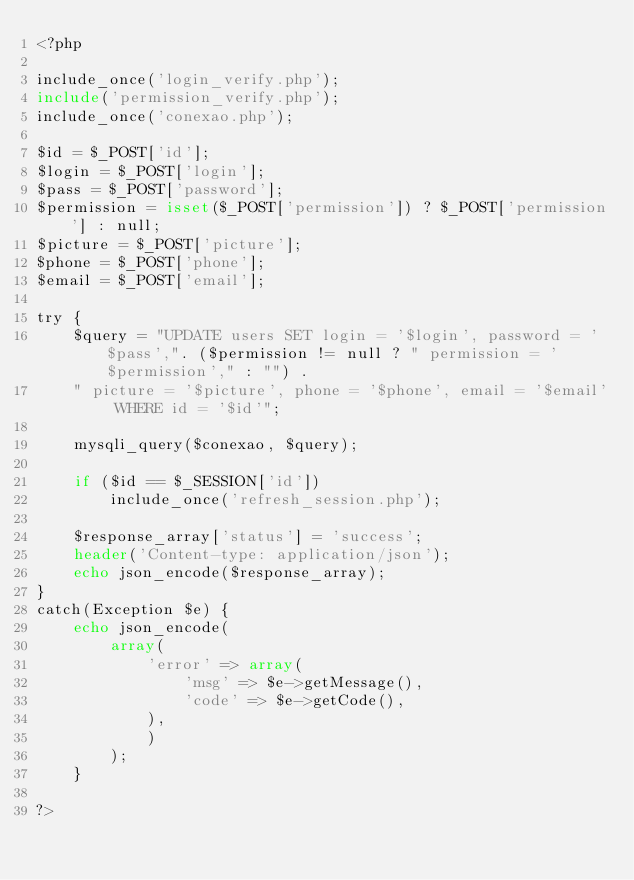<code> <loc_0><loc_0><loc_500><loc_500><_PHP_><?php

include_once('login_verify.php');
include('permission_verify.php');
include_once('conexao.php');

$id = $_POST['id'];
$login = $_POST['login'];
$pass = $_POST['password'];
$permission = isset($_POST['permission']) ? $_POST['permission'] : null;
$picture = $_POST['picture'];
$phone = $_POST['phone'];
$email = $_POST['email'];

try {
    $query = "UPDATE users SET login = '$login', password = '$pass',". ($permission != null ? " permission = '$permission'," : "") .
    " picture = '$picture', phone = '$phone', email = '$email' WHERE id = '$id'";
    
    mysqli_query($conexao, $query);

    if ($id == $_SESSION['id'])
        include_once('refresh_session.php');

    $response_array['status'] = 'success';
    header('Content-type: application/json');
    echo json_encode($response_array);
}
catch(Exception $e) {
    echo json_encode(
        array(
            'error' => array(
                'msg' => $e->getMessage(),
                'code' => $e->getCode(),
            ),
            )
        );
    }
    
?> </code> 